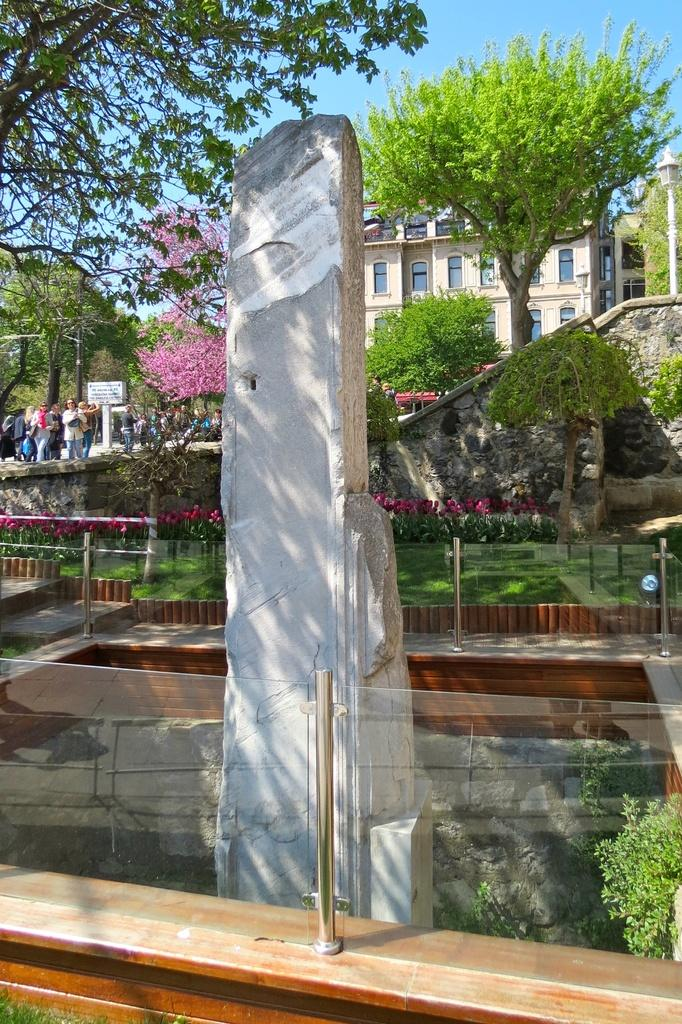What is the main object in the image? There is a stone in the image. What structures can be seen in the image? There are fences, a wall, and a building with windows in the image. What type of vegetation is present in the image? There are trees, flowers, and grass in the image. Can you describe the group of people in the image? There is a group of people in the image. What is visible in the background of the image? The sky is visible in the background of the image. What is the opinion of the fish in the image? There are no fish present in the image, so it is not possible to determine their opinion. 